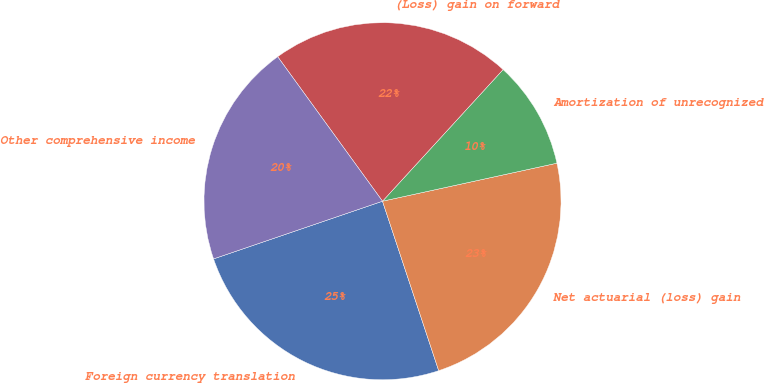Convert chart. <chart><loc_0><loc_0><loc_500><loc_500><pie_chart><fcel>Foreign currency translation<fcel>Net actuarial (loss) gain<fcel>Amortization of unrecognized<fcel>(Loss) gain on forward<fcel>Other comprehensive income<nl><fcel>24.86%<fcel>23.32%<fcel>9.78%<fcel>21.79%<fcel>20.25%<nl></chart> 